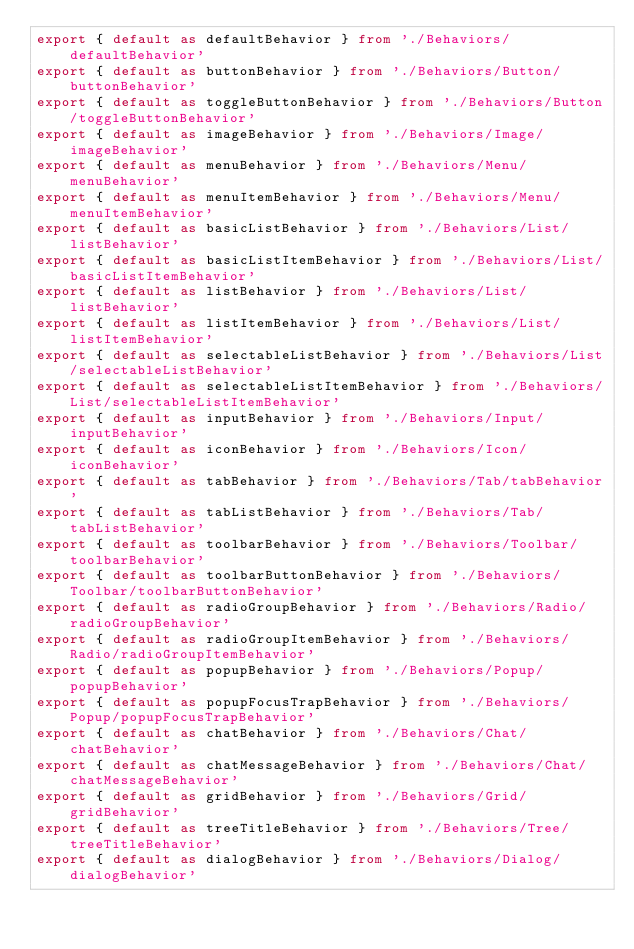Convert code to text. <code><loc_0><loc_0><loc_500><loc_500><_TypeScript_>export { default as defaultBehavior } from './Behaviors/defaultBehavior'
export { default as buttonBehavior } from './Behaviors/Button/buttonBehavior'
export { default as toggleButtonBehavior } from './Behaviors/Button/toggleButtonBehavior'
export { default as imageBehavior } from './Behaviors/Image/imageBehavior'
export { default as menuBehavior } from './Behaviors/Menu/menuBehavior'
export { default as menuItemBehavior } from './Behaviors/Menu/menuItemBehavior'
export { default as basicListBehavior } from './Behaviors/List/listBehavior'
export { default as basicListItemBehavior } from './Behaviors/List/basicListItemBehavior'
export { default as listBehavior } from './Behaviors/List/listBehavior'
export { default as listItemBehavior } from './Behaviors/List/listItemBehavior'
export { default as selectableListBehavior } from './Behaviors/List/selectableListBehavior'
export { default as selectableListItemBehavior } from './Behaviors/List/selectableListItemBehavior'
export { default as inputBehavior } from './Behaviors/Input/inputBehavior'
export { default as iconBehavior } from './Behaviors/Icon/iconBehavior'
export { default as tabBehavior } from './Behaviors/Tab/tabBehavior'
export { default as tabListBehavior } from './Behaviors/Tab/tabListBehavior'
export { default as toolbarBehavior } from './Behaviors/Toolbar/toolbarBehavior'
export { default as toolbarButtonBehavior } from './Behaviors/Toolbar/toolbarButtonBehavior'
export { default as radioGroupBehavior } from './Behaviors/Radio/radioGroupBehavior'
export { default as radioGroupItemBehavior } from './Behaviors/Radio/radioGroupItemBehavior'
export { default as popupBehavior } from './Behaviors/Popup/popupBehavior'
export { default as popupFocusTrapBehavior } from './Behaviors/Popup/popupFocusTrapBehavior'
export { default as chatBehavior } from './Behaviors/Chat/chatBehavior'
export { default as chatMessageBehavior } from './Behaviors/Chat/chatMessageBehavior'
export { default as gridBehavior } from './Behaviors/Grid/gridBehavior'
export { default as treeTitleBehavior } from './Behaviors/Tree/treeTitleBehavior'
export { default as dialogBehavior } from './Behaviors/Dialog/dialogBehavior'
</code> 